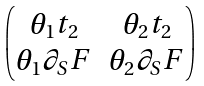<formula> <loc_0><loc_0><loc_500><loc_500>\begin{pmatrix} \theta _ { 1 } t _ { 2 } & \theta _ { 2 } t _ { 2 } \\ \theta _ { 1 } \partial _ { S } F & \theta _ { 2 } \partial _ { S } F \end{pmatrix}</formula> 